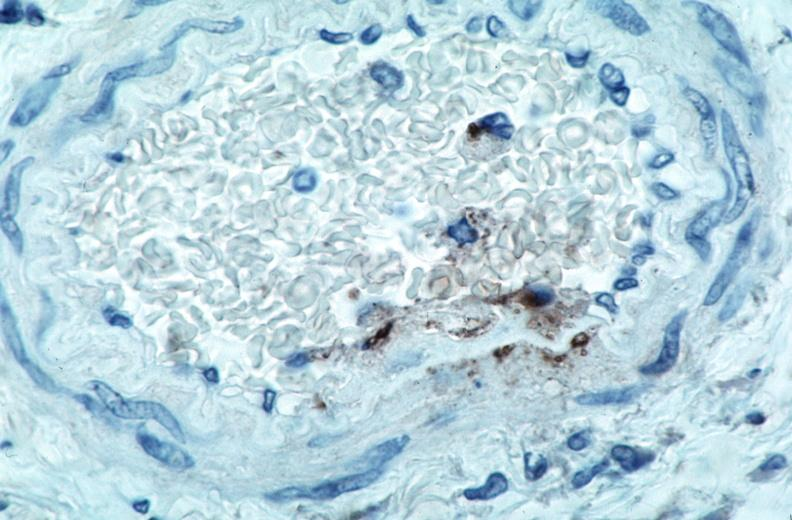s newborn cord around neck present?
Answer the question using a single word or phrase. No 